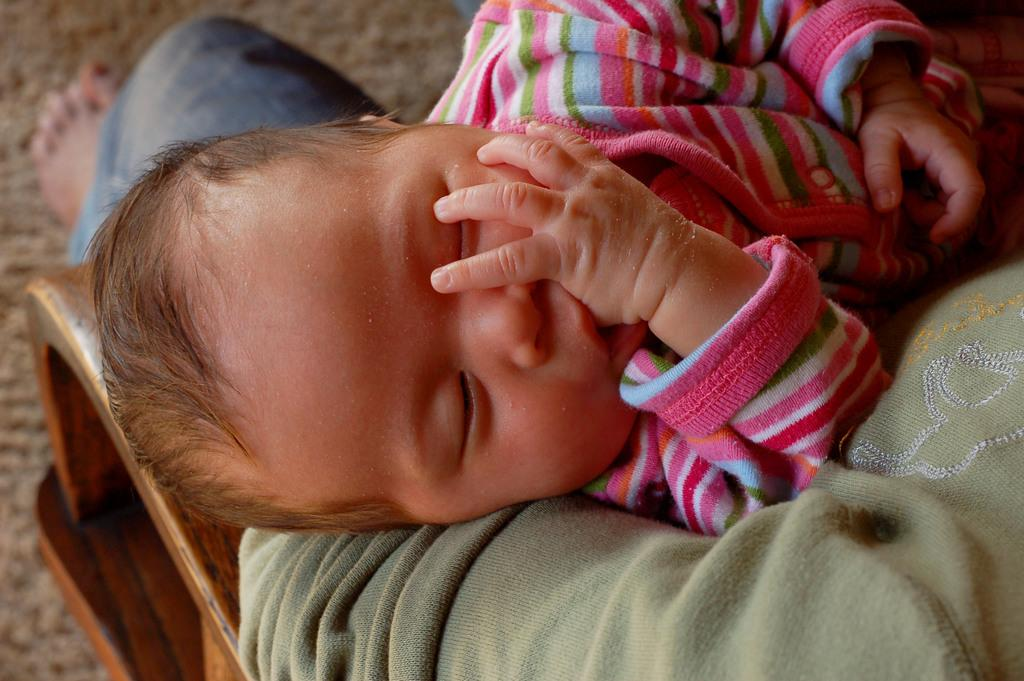What is the person in the image doing? The person is sitting in the image and holding a child. What is the condition of the child in the image? The child is sleeping. What is at the bottom of the image? There is a mat at the bottom of the image. What type of soup is being served on the wood in the image? There is no soup or wood present in the image; it features a person sitting and holding a sleeping child on a mat. 